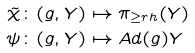<formula> <loc_0><loc_0><loc_500><loc_500>\tilde { \chi } & \colon ( g , Y ) \mapsto \pi _ { \geq r h } ( Y ) \\ \psi & \colon ( g , Y ) \mapsto A d ( g ) Y</formula> 